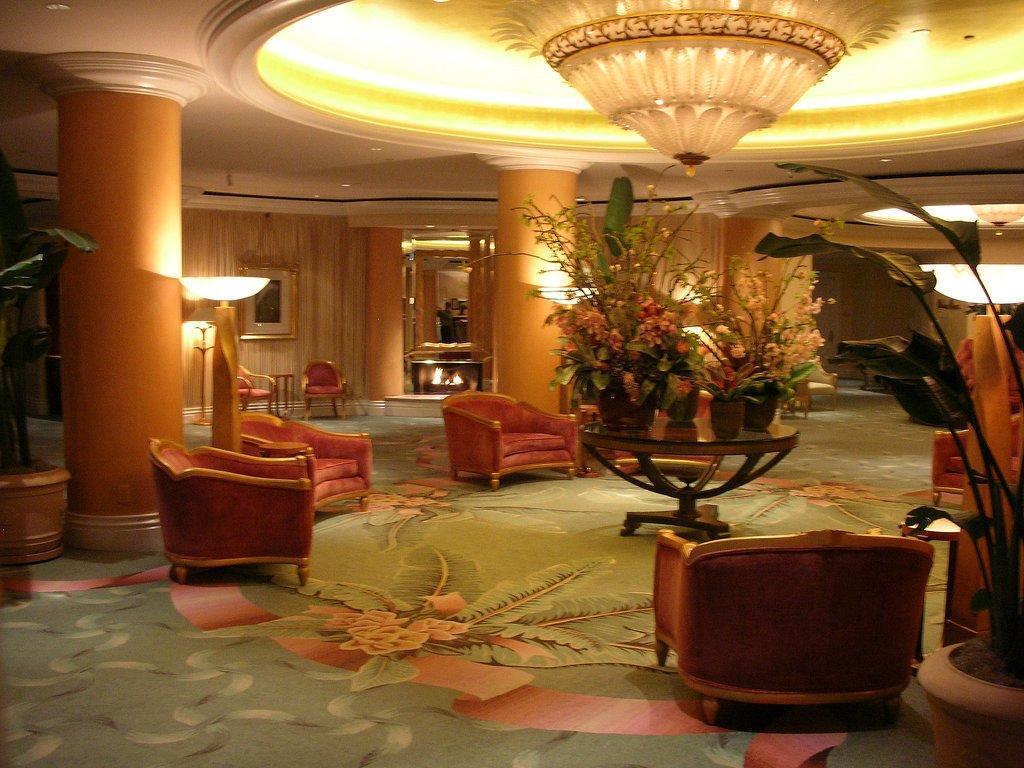Could you give a brief overview of what you see in this image? This is a picture taken in a hotel, this is looking like a hall on the hall there a red color chairs. On middle of the hall there is a table on the table there are flower pots. On top of the flower pot there is a chandelier. Background of the chair there are pillar and a wall with photos. 